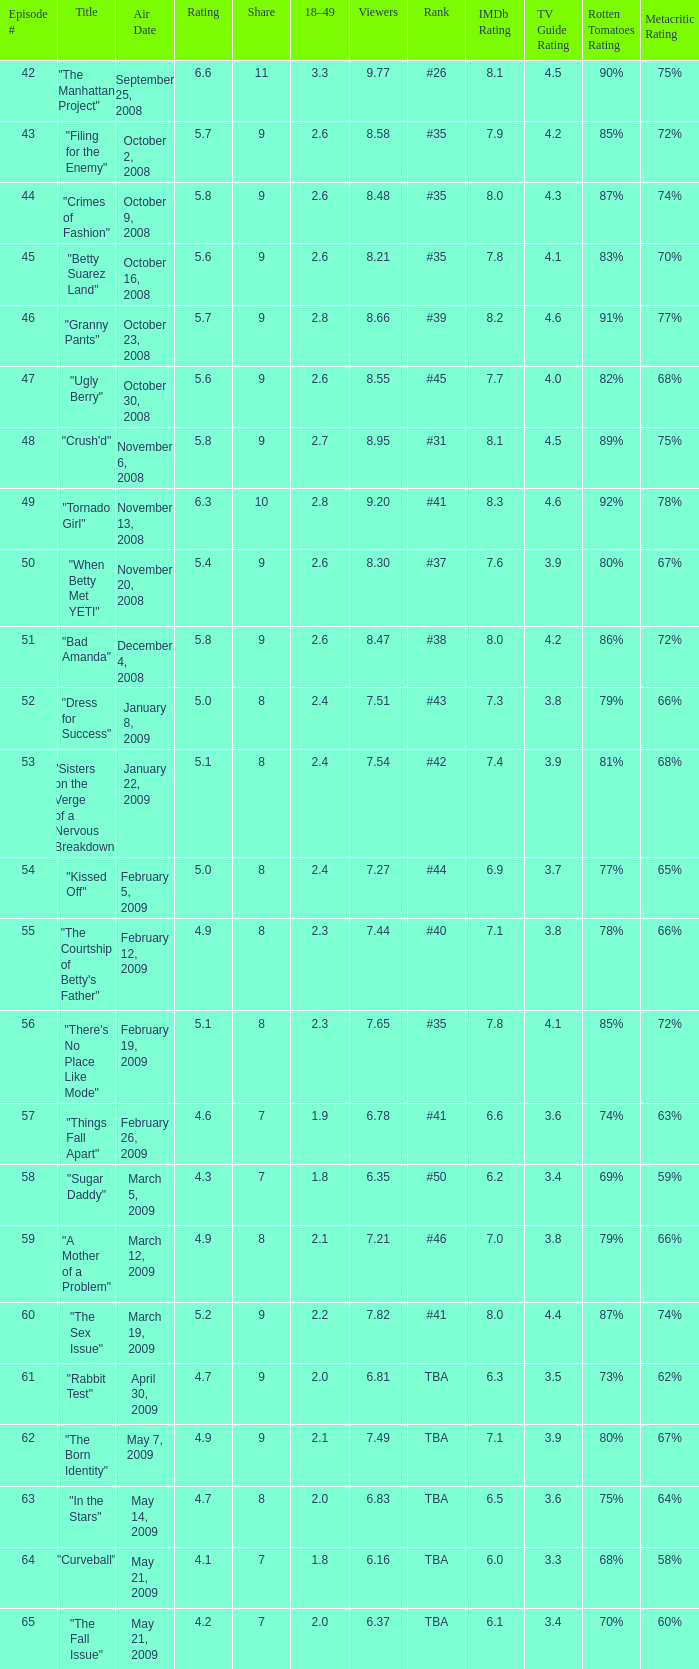What is the average Episode # with a share of 9, and #35 is rank and less than 8.21 viewers? None. 